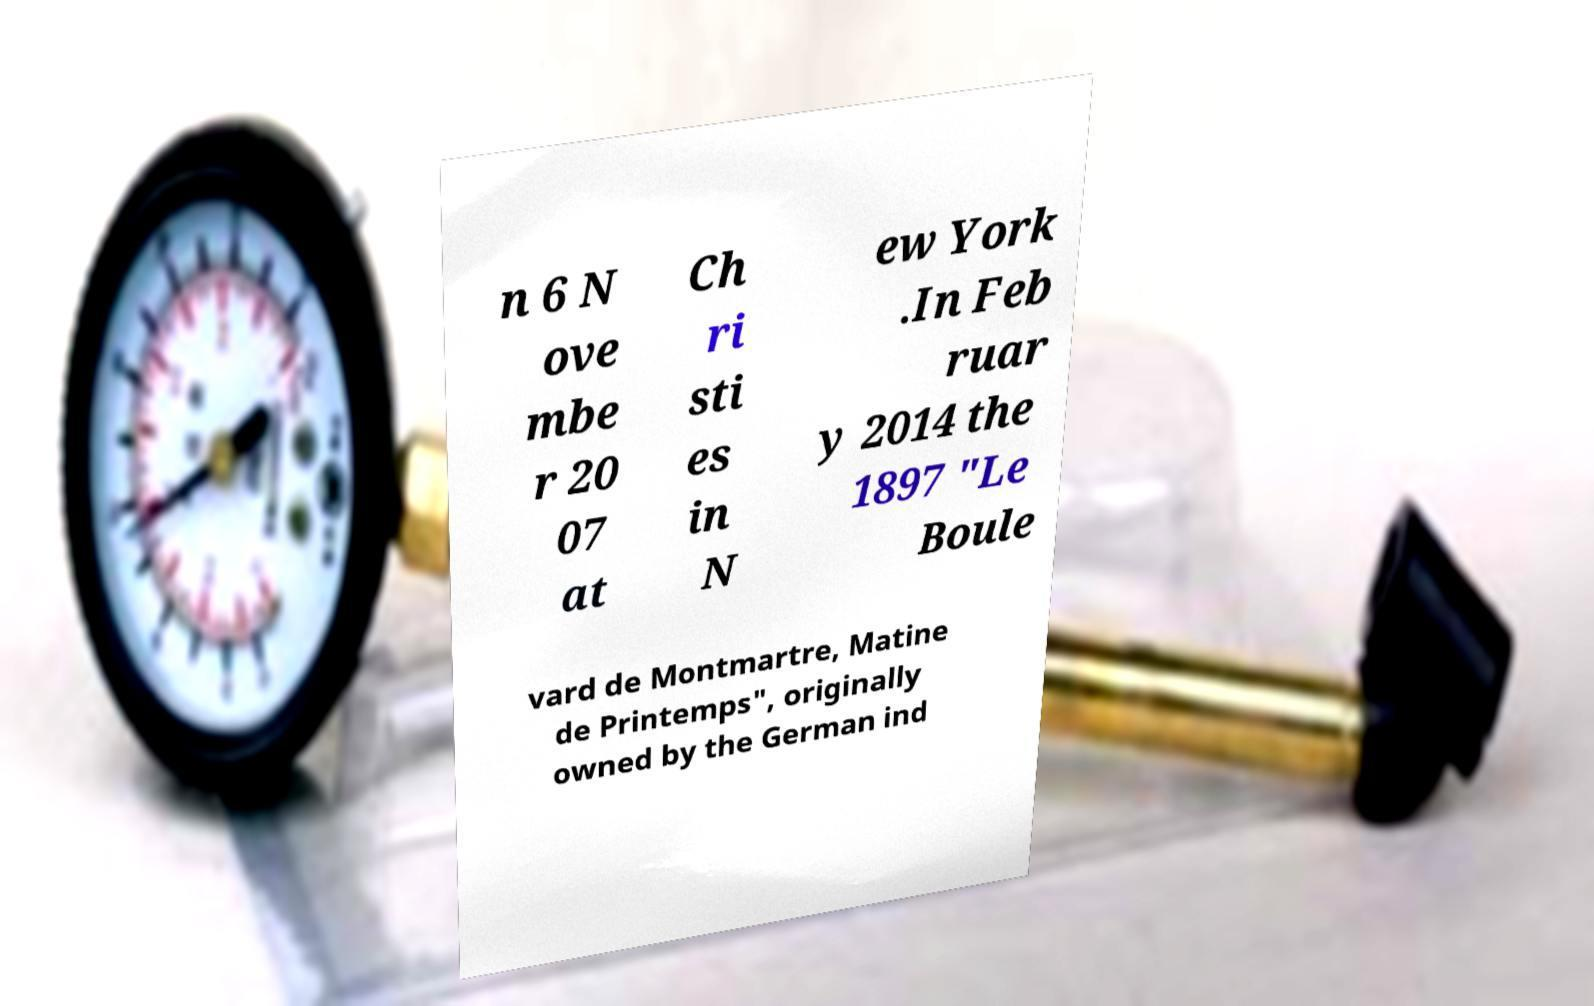There's text embedded in this image that I need extracted. Can you transcribe it verbatim? n 6 N ove mbe r 20 07 at Ch ri sti es in N ew York .In Feb ruar y 2014 the 1897 "Le Boule vard de Montmartre, Matine de Printemps", originally owned by the German ind 